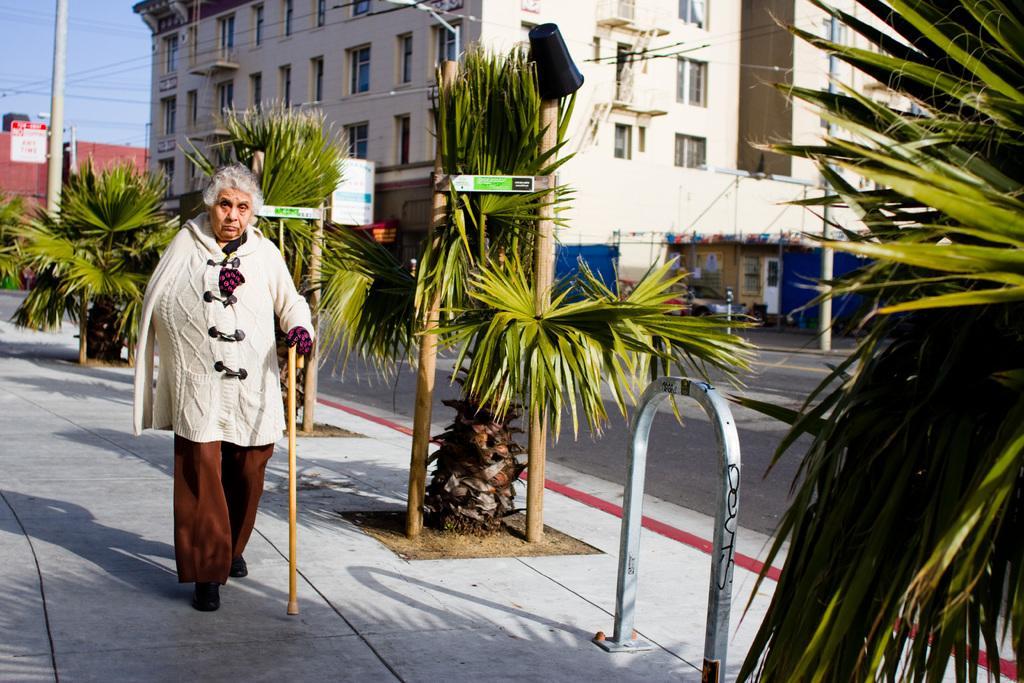Please provide a concise description of this image. In this image I can see the person with white and brown color dress and the person is holding the stick. To the side of the person there are many plants and poles. In the background I can see the road, buildings and the sky. 